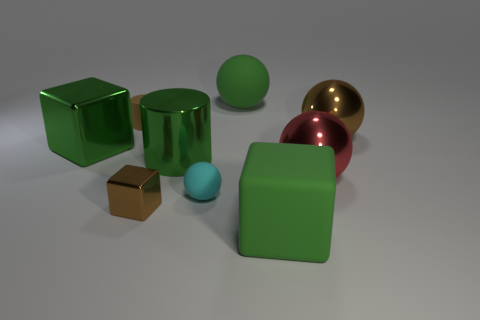Subtract all cyan cylinders. How many green blocks are left? 2 Subtract 1 cubes. How many cubes are left? 2 Subtract all red balls. How many balls are left? 3 Subtract all green blocks. How many blocks are left? 1 Add 1 large green matte blocks. How many objects exist? 10 Subtract all yellow balls. Subtract all purple cylinders. How many balls are left? 4 Subtract all blocks. How many objects are left? 6 Subtract 0 yellow blocks. How many objects are left? 9 Subtract all tiny purple cubes. Subtract all small metallic blocks. How many objects are left? 8 Add 7 large red metallic objects. How many large red metallic objects are left? 8 